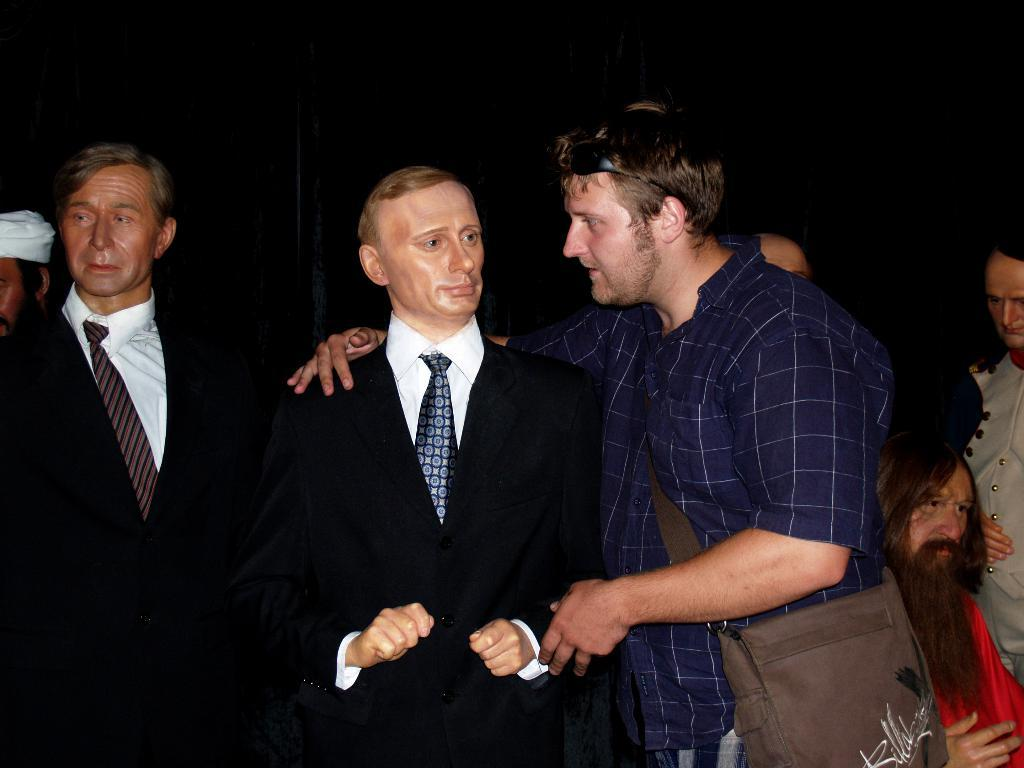What can be seen in the image? There are some statues in the image. Can you describe the man's position in the image? There is a man standing beside one of the statues. What type of goat can be seen grazing in the garden near the statues? There is no goat or garden present in the image; it only features statues and a man standing beside one of them. 